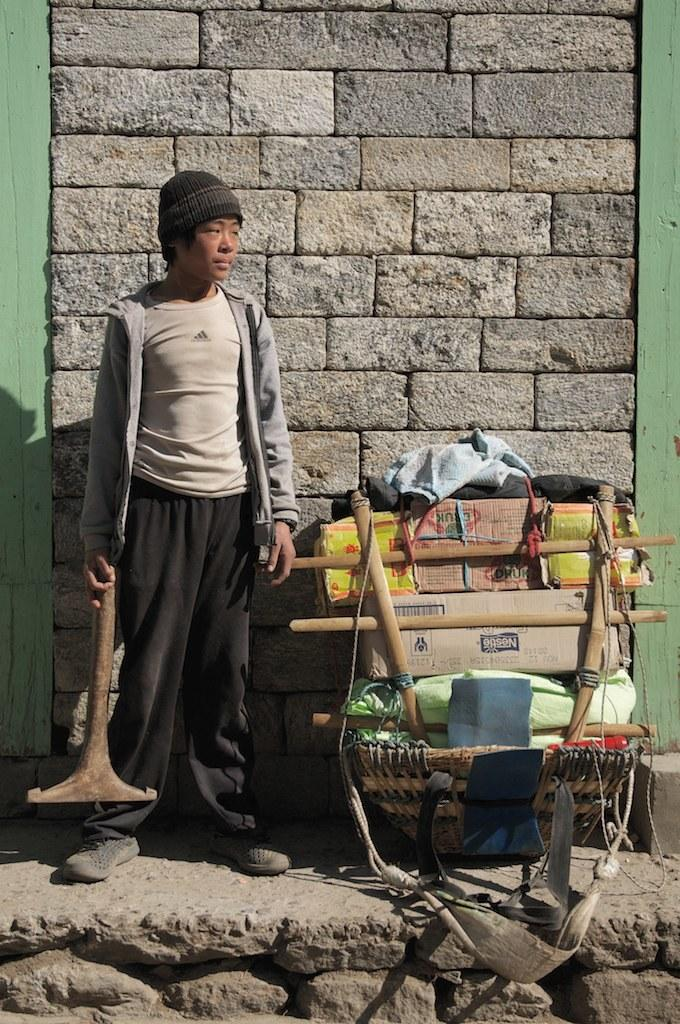What is the person in the image doing? The person is standing in the image and holding an object. What can be seen in the image besides the person? There are cardboard boxes, clothes, a basket, belts, and other objects in the image. What is the background of the image like? There is a wall visible in the background. How far away is the hand from the bulb in the image? There is no hand or bulb present in the image. 